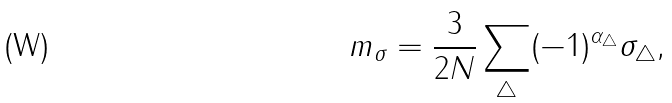Convert formula to latex. <formula><loc_0><loc_0><loc_500><loc_500>m _ { \sigma } = \frac { 3 } { 2 N } \sum _ { \bigtriangleup } ( - 1 ) ^ { \alpha _ { \bigtriangleup } } \sigma _ { \bigtriangleup } ,</formula> 